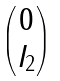<formula> <loc_0><loc_0><loc_500><loc_500>\begin{pmatrix} 0 \\ I _ { 2 } \end{pmatrix}</formula> 